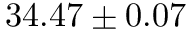Convert formula to latex. <formula><loc_0><loc_0><loc_500><loc_500>3 4 . 4 7 \pm 0 . 0 7</formula> 